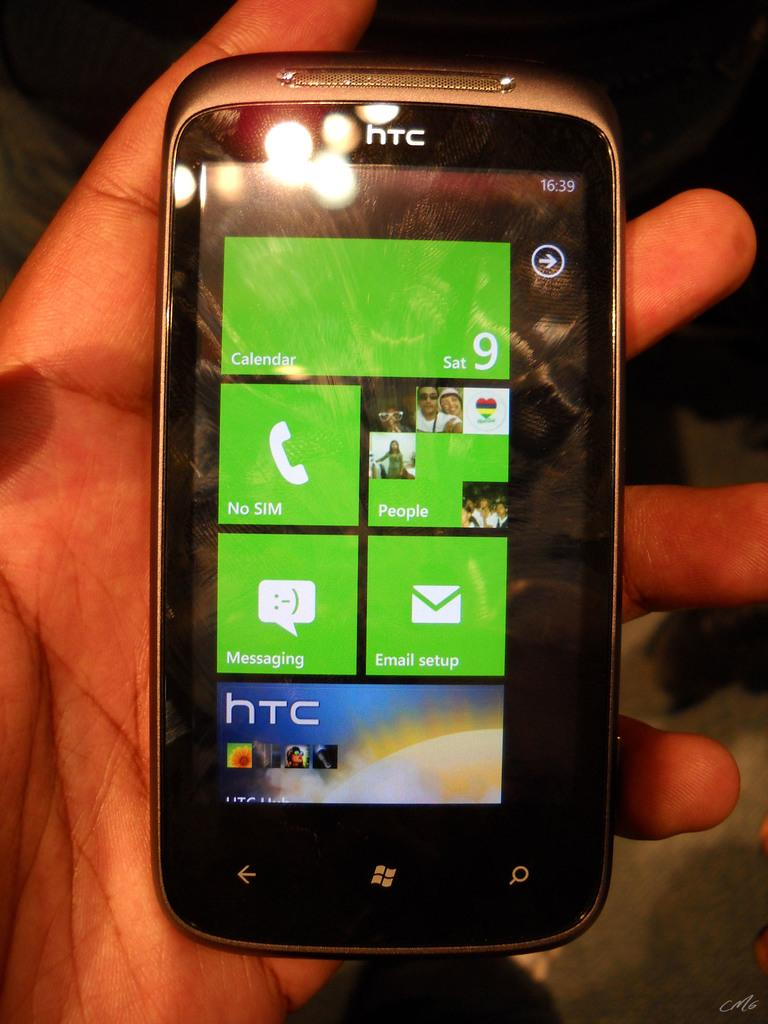What part of a person can be seen in the image? There is a person's hand in the image. What is the person holding in their hand? The person is holding a mobile phone. What can be seen on the mobile phone screen? There are pictures and text visible on the mobile phone screen. What type of slip is the person wearing on their hand in the image? There is no slip visible on the person's hand in the image. 